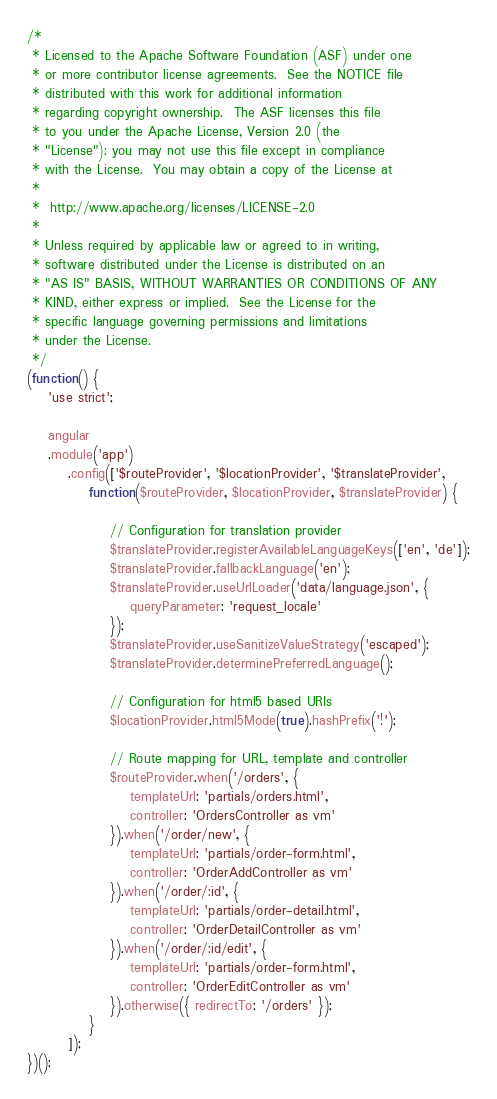Convert code to text. <code><loc_0><loc_0><loc_500><loc_500><_JavaScript_>/*
 * Licensed to the Apache Software Foundation (ASF) under one
 * or more contributor license agreements.  See the NOTICE file
 * distributed with this work for additional information
 * regarding copyright ownership.  The ASF licenses this file
 * to you under the Apache License, Version 2.0 (the
 * "License"); you may not use this file except in compliance
 * with the License.  You may obtain a copy of the License at
 *
 *  http://www.apache.org/licenses/LICENSE-2.0
 *
 * Unless required by applicable law or agreed to in writing,
 * software distributed under the License is distributed on an
 * "AS IS" BASIS, WITHOUT WARRANTIES OR CONDITIONS OF ANY
 * KIND, either express or implied.  See the License for the
 * specific language governing permissions and limitations
 * under the License.
 */
(function() {
    'use strict';

    angular
    .module('app')
        .config(['$routeProvider', '$locationProvider', '$translateProvider',
            function($routeProvider, $locationProvider, $translateProvider) {

                // Configuration for translation provider
                $translateProvider.registerAvailableLanguageKeys(['en', 'de']);
                $translateProvider.fallbackLanguage('en');
                $translateProvider.useUrlLoader('data/language.json', {
                    queryParameter: 'request_locale'
                });
                $translateProvider.useSanitizeValueStrategy('escaped');
                $translateProvider.determinePreferredLanguage();

                // Configuration for html5 based URIs
                $locationProvider.html5Mode(true).hashPrefix('!');

                // Route mapping for URL, template and controller
                $routeProvider.when('/orders', {
                    templateUrl: 'partials/orders.html',
                    controller: 'OrdersController as vm'
                }).when('/order/new', {
                    templateUrl: 'partials/order-form.html',
                    controller: 'OrderAddController as vm'
                }).when('/order/:id', {
                    templateUrl: 'partials/order-detail.html',
                    controller: 'OrderDetailController as vm'
                }).when('/order/:id/edit', {
                    templateUrl: 'partials/order-form.html',
                    controller: 'OrderEditController as vm'
                }).otherwise({ redirectTo: '/orders' });
            }
        ]);
})();
</code> 